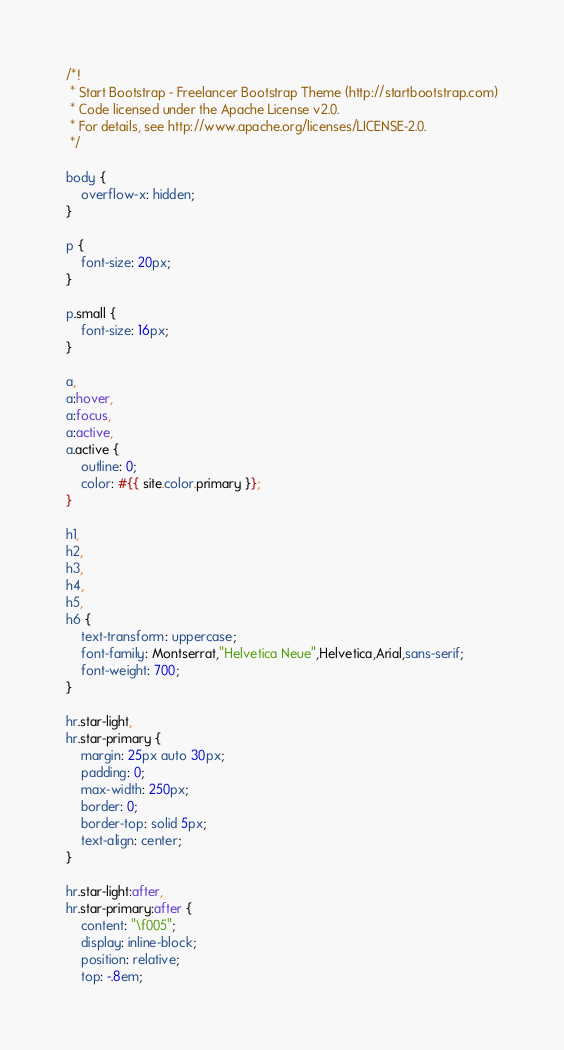<code> <loc_0><loc_0><loc_500><loc_500><_CSS_>/*!
 * Start Bootstrap - Freelancer Bootstrap Theme (http://startbootstrap.com)
 * Code licensed under the Apache License v2.0.
 * For details, see http://www.apache.org/licenses/LICENSE-2.0.
 */

body {
    overflow-x: hidden;
}

p {
    font-size: 20px;
}

p.small {
    font-size: 16px;
}

a,
a:hover,
a:focus,
a:active,
a.active {
    outline: 0;
    color: #{{ site.color.primary }};
}

h1,
h2,
h3,
h4,
h5,
h6 {
    text-transform: uppercase;
    font-family: Montserrat,"Helvetica Neue",Helvetica,Arial,sans-serif;
    font-weight: 700;
}

hr.star-light,
hr.star-primary {
    margin: 25px auto 30px;
    padding: 0;
    max-width: 250px;
    border: 0;
    border-top: solid 5px;
    text-align: center;
}

hr.star-light:after,
hr.star-primary:after {
    content: "\f005";
    display: inline-block;
    position: relative;
    top: -.8em;</code> 